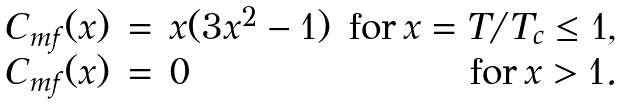<formula> <loc_0><loc_0><loc_500><loc_500>\begin{array} { r c l r } C _ { m f } ( x ) & = & x ( 3 x ^ { 2 } - 1 ) & \text {for} \, x = T / T _ { c } \leq 1 , \\ C _ { m f } ( x ) & = & 0 & \text {for} \, x > 1 . \end{array}</formula> 